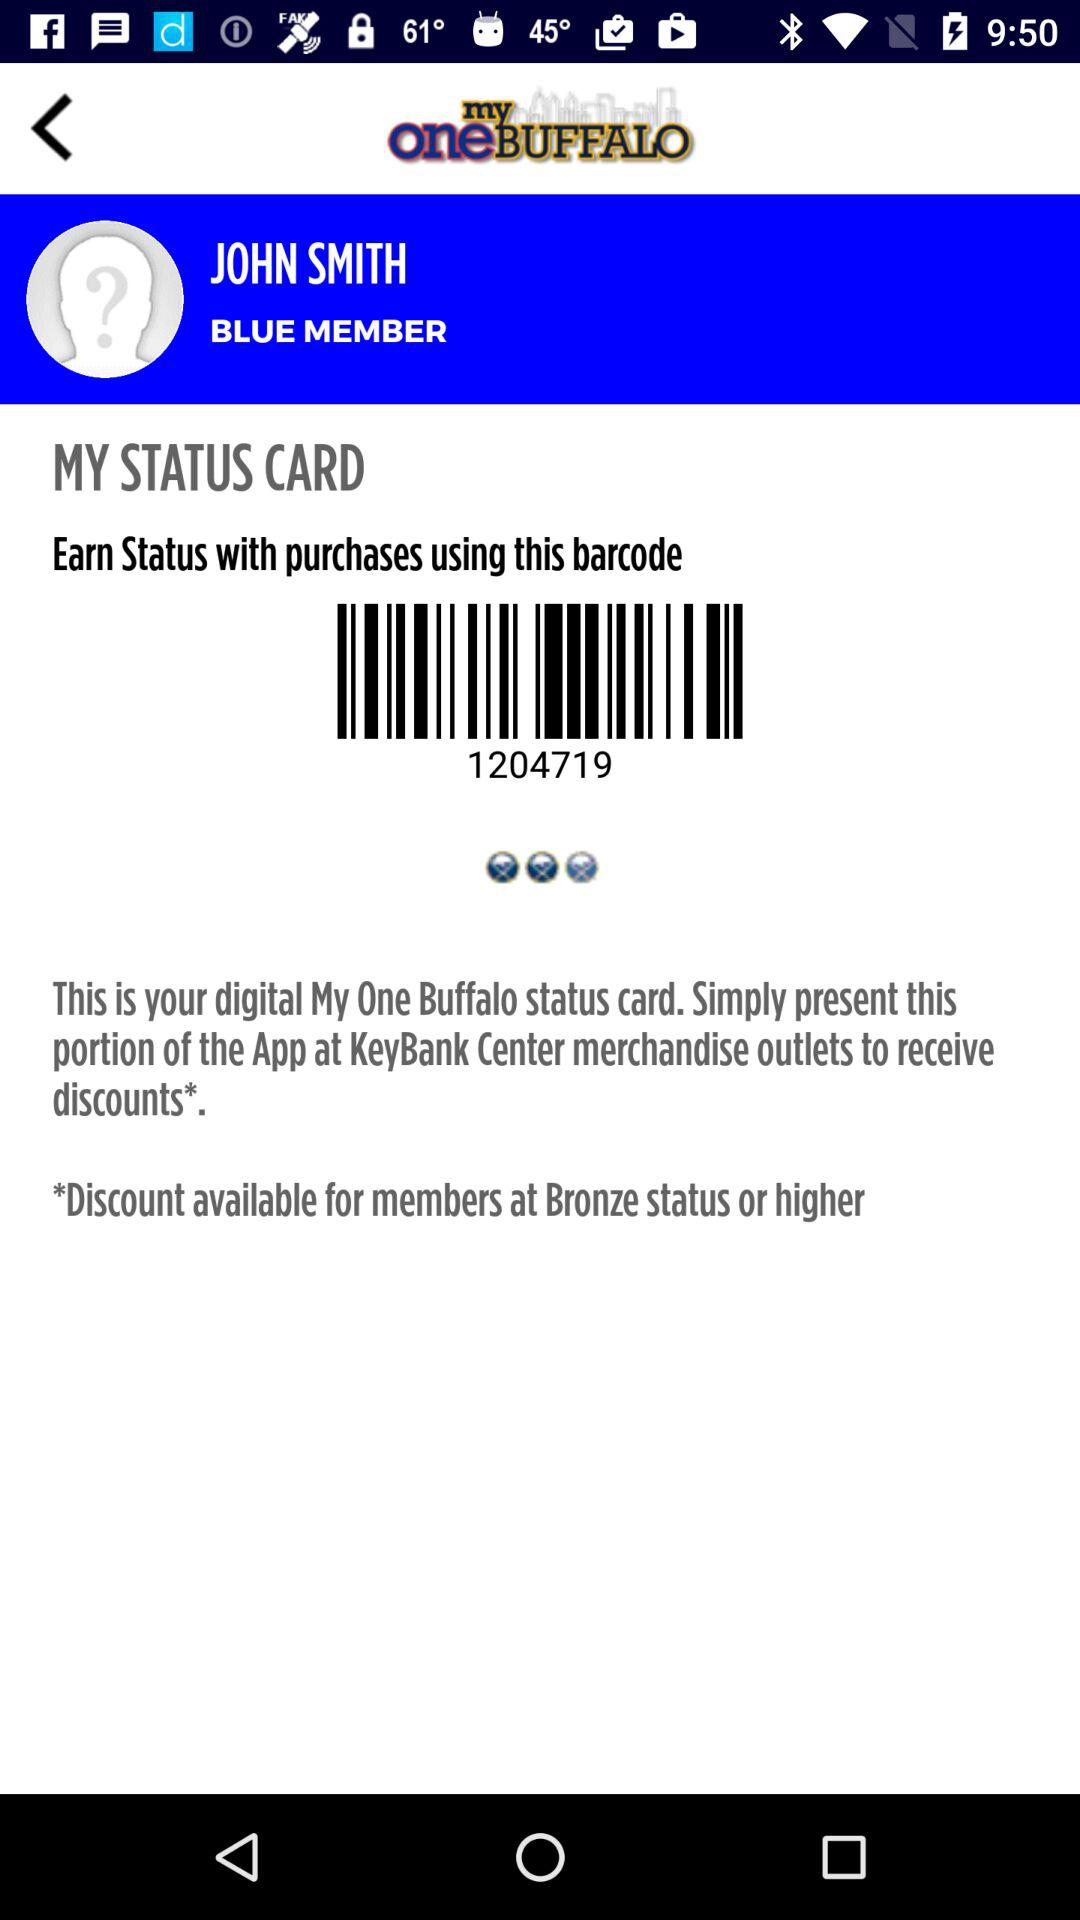Which color membership is the person enrolled in? The person is enrolled in blue color membership. 